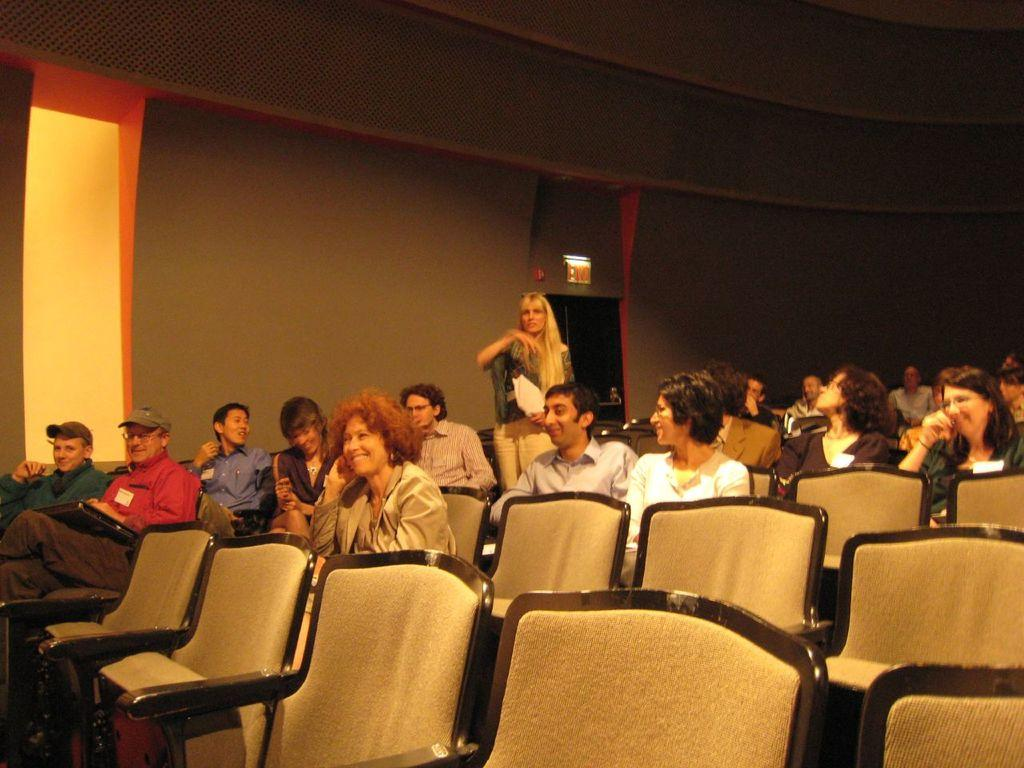What are the people in the room doing? The people in the room are sitting in chairs. Can you describe the composition of the group? There are both men and women in the group. What is the position of one of the women in the room? One woman is standing in the room. What can be seen in the background of the room? There is a wall in the background of the room. Who is the owner of the woman in the room? There is no indication in the image that any of the people in the room own another person. How does the woman in the room pull the chair towards her? The image does not show the woman pulling a chair; she is standing, and there are people sitting in chairs. 